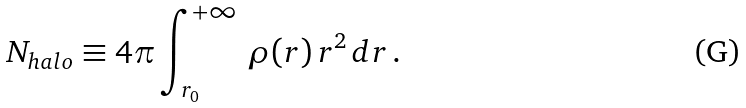Convert formula to latex. <formula><loc_0><loc_0><loc_500><loc_500>N _ { h a l o } \equiv 4 \pi \int _ { r _ { 0 } } ^ { + \infty } \, \rho ( r ) \, r ^ { 2 } \, d r \, .</formula> 